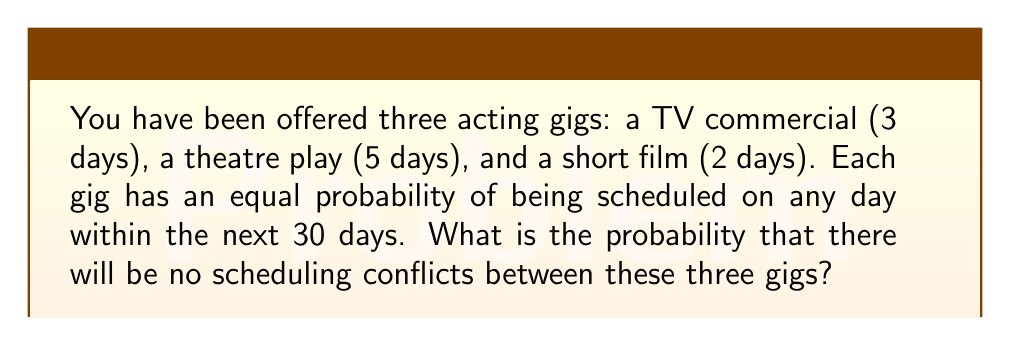Can you answer this question? Let's approach this step-by-step:

1) First, we need to calculate the probability of no conflicts for each pair of gigs:

   a) TV commercial and theatre play:
      Favorable outcomes = $30 - (3 + 5 - 1) = 23$ days
      Probability = $\frac{23}{30}$

   b) TV commercial and short film:
      Favorable outcomes = $30 - (3 + 2 - 1) = 26$ days
      Probability = $\frac{26}{30}$

   c) Theatre play and short film:
      Favorable outcomes = $30 - (5 + 2 - 1) = 24$ days
      Probability = $\frac{24}{30}$

2) The probability of no conflicts among all three gigs is the product of these individual probabilities:

   $$P(\text{no conflicts}) = \frac{23}{30} \times \frac{26}{30} \times \frac{24}{30}$$

3) Simplifying:
   $$P(\text{no conflicts}) = \frac{23 \times 26 \times 24}{30^3} = \frac{14,352}{27,000}$$

4) Reducing the fraction:
   $$P(\text{no conflicts}) = \frac{1,794}{3,375} \approx 0.5316$$

Therefore, the probability of no scheduling conflicts is approximately 0.5316 or about 53.16%.
Answer: $\frac{1,794}{3,375}$ or approximately 0.5316 